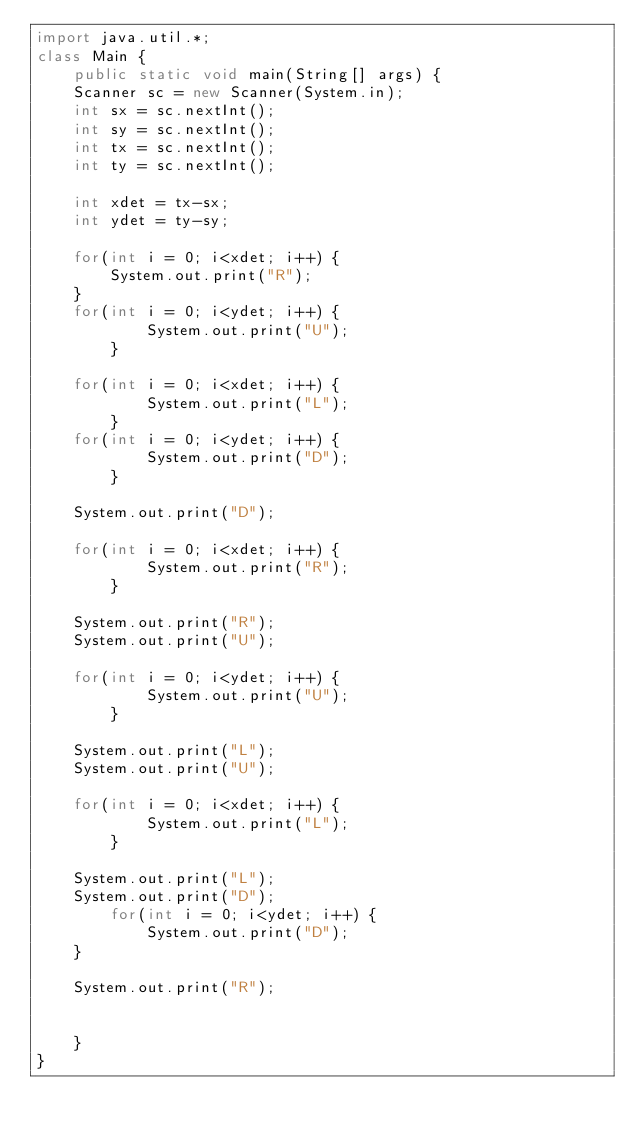Convert code to text. <code><loc_0><loc_0><loc_500><loc_500><_Java_>import java.util.*;
class Main {
    public static void main(String[] args) {
	Scanner sc = new Scanner(System.in);
	int sx = sc.nextInt();
	int sy = sc.nextInt();
	int tx = sc.nextInt();
	int ty = sc.nextInt();

	int xdet = tx-sx;
	int ydet = ty-sy;

	for(int i = 0; i<xdet; i++) {
	    System.out.print("R");
	}
	for(int i = 0; i<ydet; i++) {
            System.out.print("U");
        }

	for(int i = 0; i<xdet; i++) {
            System.out.print("L");
        }
	for(int i = 0; i<ydet; i++) {
            System.out.print("D");
        }

	System.out.print("D");

	for(int i = 0; i<xdet; i++) {
            System.out.print("R");
        }

	System.out.print("R");
	System.out.print("U");

	for(int i = 0; i<ydet; i++) {
            System.out.print("U");
        }

	System.out.print("L");
	System.out.print("U");

	for(int i = 0; i<xdet; i++) {
            System.out.print("L");
        }

	System.out.print("L");
	System.out.print("D");
        for(int i = 0; i<ydet; i++) {
            System.out.print("D");
	}

	System.out.print("R");


    }
}</code> 